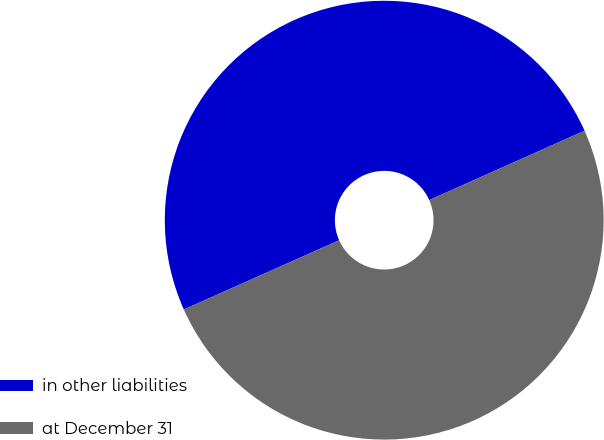Convert chart to OTSL. <chart><loc_0><loc_0><loc_500><loc_500><pie_chart><fcel>in other liabilities<fcel>at December 31<nl><fcel>49.99%<fcel>50.01%<nl></chart> 